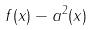Convert formula to latex. <formula><loc_0><loc_0><loc_500><loc_500>f ( x ) - a ^ { 2 } ( x )</formula> 